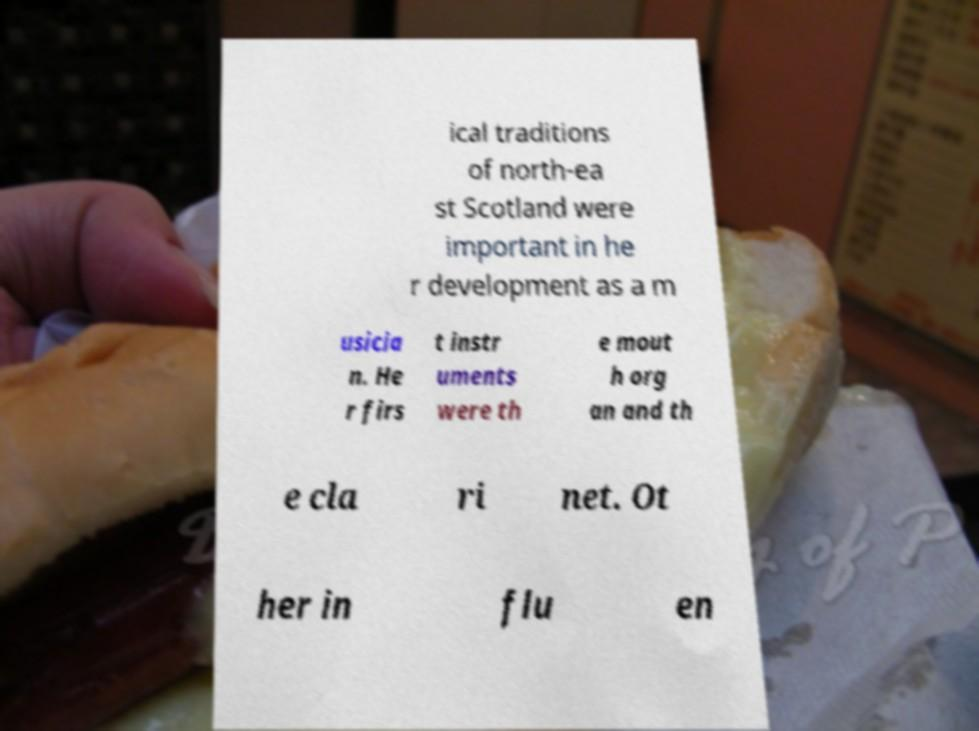I need the written content from this picture converted into text. Can you do that? ical traditions of north-ea st Scotland were important in he r development as a m usicia n. He r firs t instr uments were th e mout h org an and th e cla ri net. Ot her in flu en 